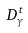Convert formula to latex. <formula><loc_0><loc_0><loc_500><loc_500>D _ { \gamma } ^ { t }</formula> 